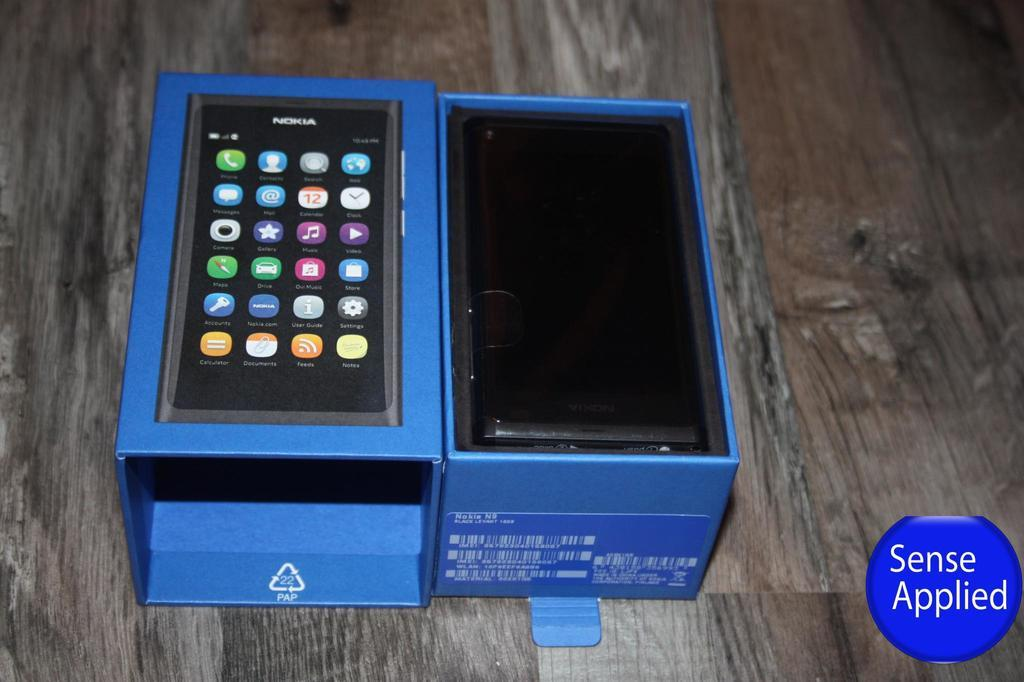<image>
Share a concise interpretation of the image provided. An electronic device in a box with a circle in the corner that says Sense Applied. 